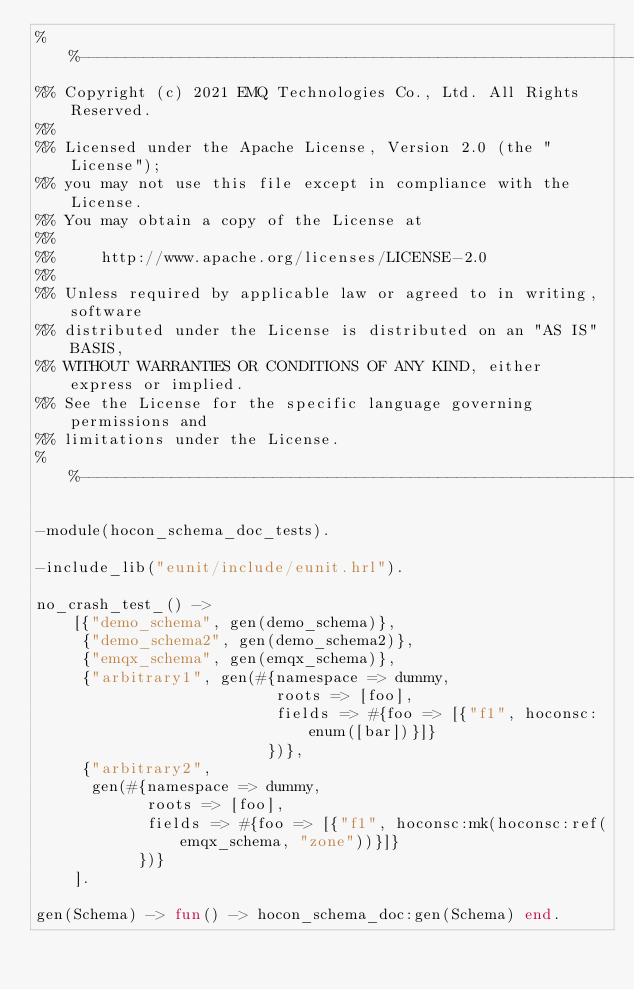<code> <loc_0><loc_0><loc_500><loc_500><_Erlang_>%%--------------------------------------------------------------------
%% Copyright (c) 2021 EMQ Technologies Co., Ltd. All Rights Reserved.
%%
%% Licensed under the Apache License, Version 2.0 (the "License");
%% you may not use this file except in compliance with the License.
%% You may obtain a copy of the License at
%%
%%     http://www.apache.org/licenses/LICENSE-2.0
%%
%% Unless required by applicable law or agreed to in writing, software
%% distributed under the License is distributed on an "AS IS" BASIS,
%% WITHOUT WARRANTIES OR CONDITIONS OF ANY KIND, either express or implied.
%% See the License for the specific language governing permissions and
%% limitations under the License.
%%--------------------------------------------------------------------

-module(hocon_schema_doc_tests).

-include_lib("eunit/include/eunit.hrl").

no_crash_test_() ->
    [{"demo_schema", gen(demo_schema)},
     {"demo_schema2", gen(demo_schema2)},
     {"emqx_schema", gen(emqx_schema)},
     {"arbitrary1", gen(#{namespace => dummy,
                          roots => [foo],
                          fields => #{foo => [{"f1", hoconsc:enum([bar])}]}
                         })},
     {"arbitrary2",
      gen(#{namespace => dummy,
            roots => [foo],
            fields => #{foo => [{"f1", hoconsc:mk(hoconsc:ref(emqx_schema, "zone"))}]}
           })}
    ].

gen(Schema) -> fun() -> hocon_schema_doc:gen(Schema) end.
</code> 